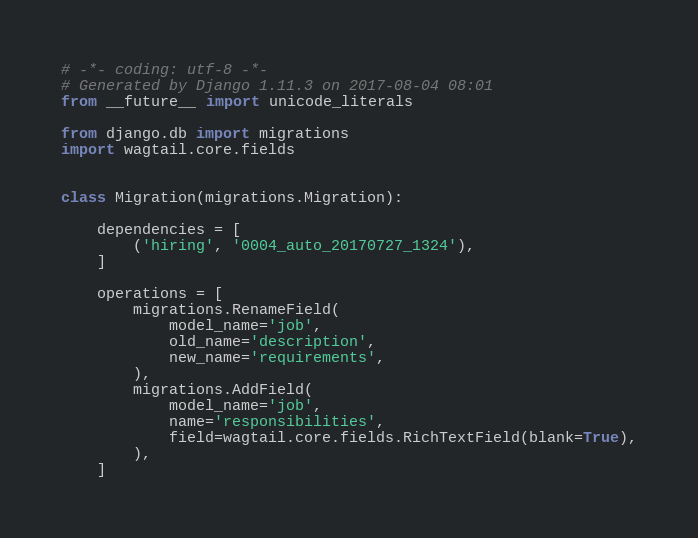<code> <loc_0><loc_0><loc_500><loc_500><_Python_># -*- coding: utf-8 -*-
# Generated by Django 1.11.3 on 2017-08-04 08:01
from __future__ import unicode_literals

from django.db import migrations
import wagtail.core.fields


class Migration(migrations.Migration):

    dependencies = [
        ('hiring', '0004_auto_20170727_1324'),
    ]

    operations = [
        migrations.RenameField(
            model_name='job',
            old_name='description',
            new_name='requirements',
        ),
        migrations.AddField(
            model_name='job',
            name='responsibilities',
            field=wagtail.core.fields.RichTextField(blank=True),
        ),
    ]
</code> 